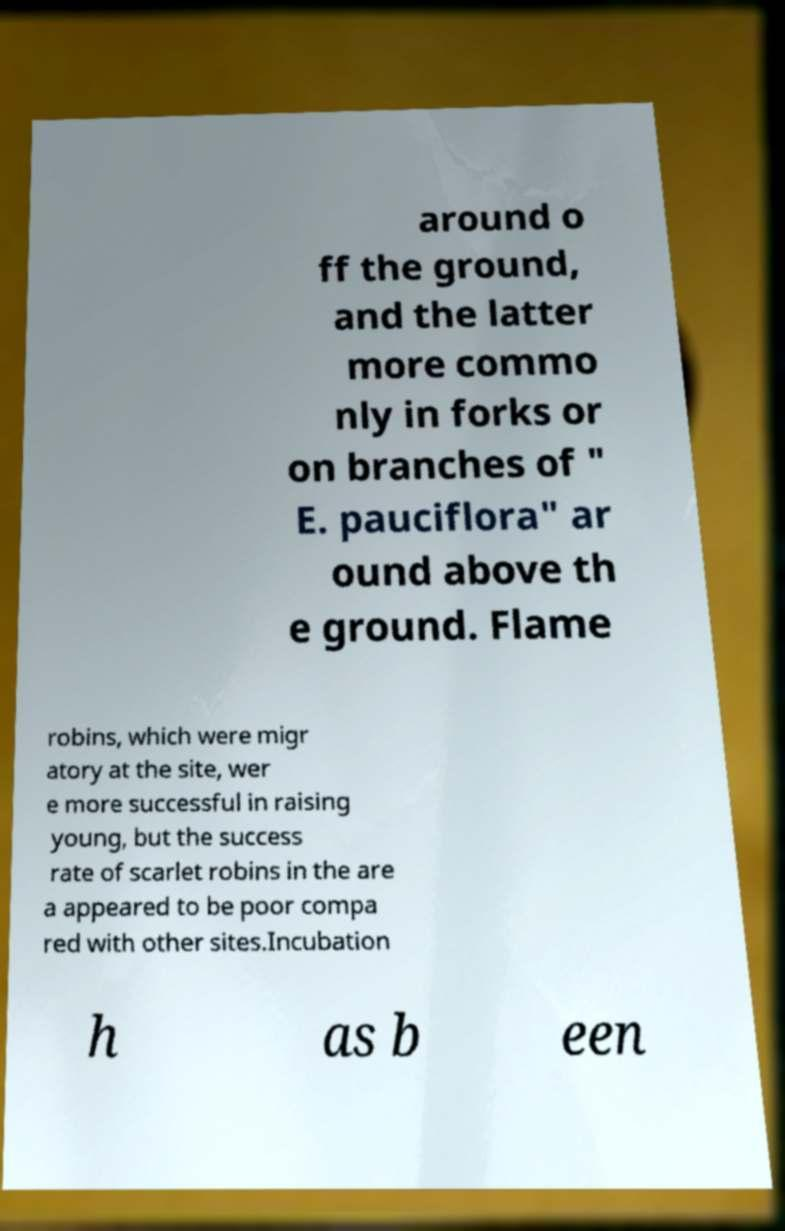I need the written content from this picture converted into text. Can you do that? around o ff the ground, and the latter more commo nly in forks or on branches of " E. pauciflora" ar ound above th e ground. Flame robins, which were migr atory at the site, wer e more successful in raising young, but the success rate of scarlet robins in the are a appeared to be poor compa red with other sites.Incubation h as b een 